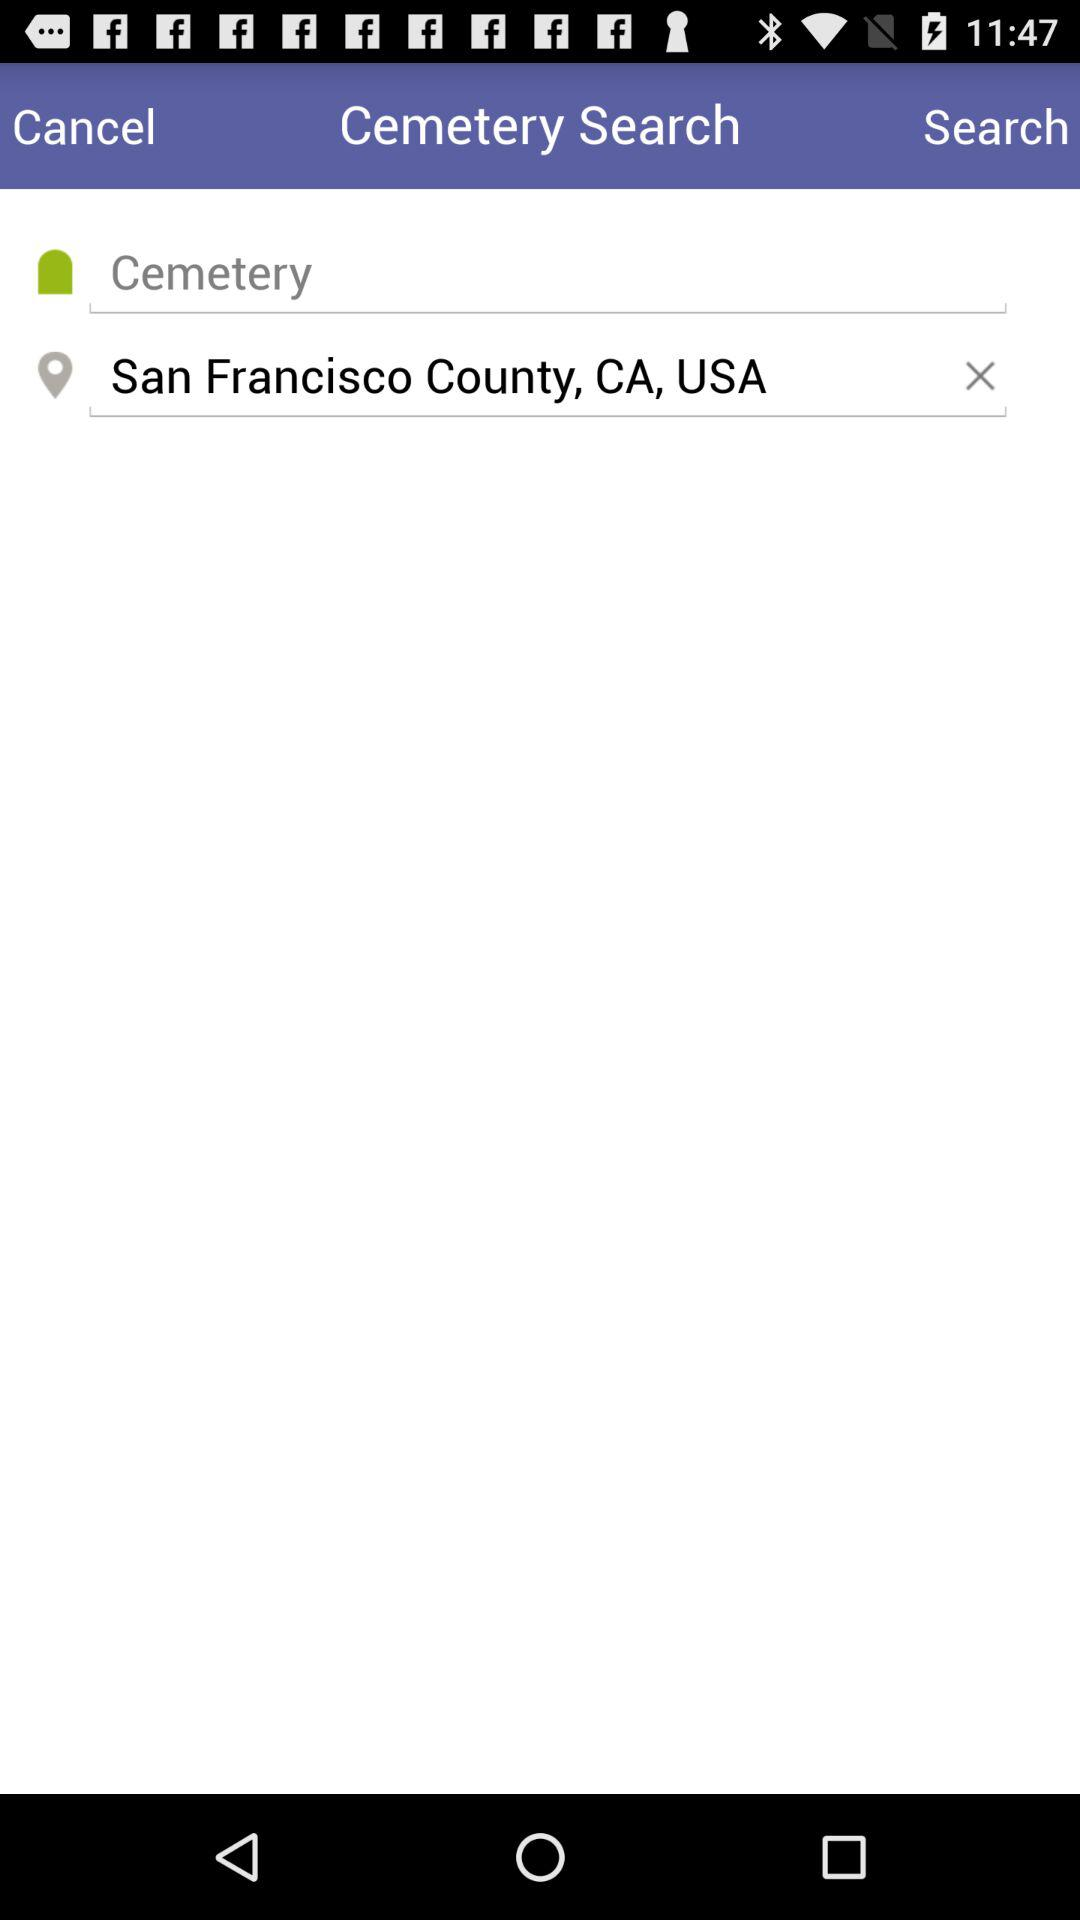What country's name is shown on the screen? The country's name is "USA". 